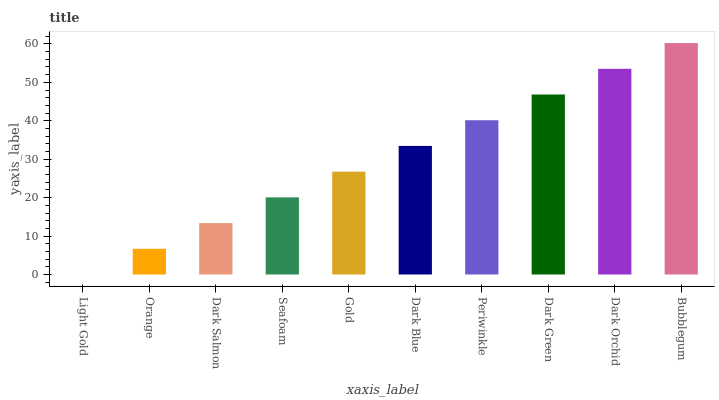Is Light Gold the minimum?
Answer yes or no. Yes. Is Bubblegum the maximum?
Answer yes or no. Yes. Is Orange the minimum?
Answer yes or no. No. Is Orange the maximum?
Answer yes or no. No. Is Orange greater than Light Gold?
Answer yes or no. Yes. Is Light Gold less than Orange?
Answer yes or no. Yes. Is Light Gold greater than Orange?
Answer yes or no. No. Is Orange less than Light Gold?
Answer yes or no. No. Is Dark Blue the high median?
Answer yes or no. Yes. Is Gold the low median?
Answer yes or no. Yes. Is Dark Green the high median?
Answer yes or no. No. Is Orange the low median?
Answer yes or no. No. 